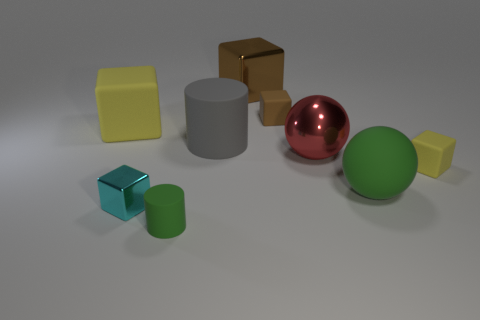How would you describe the arrangement of objects? The objects are arranged with ample space between them, seemingly random but aesthetically pleasing, with a variety of geometric shapes and colors represented. 